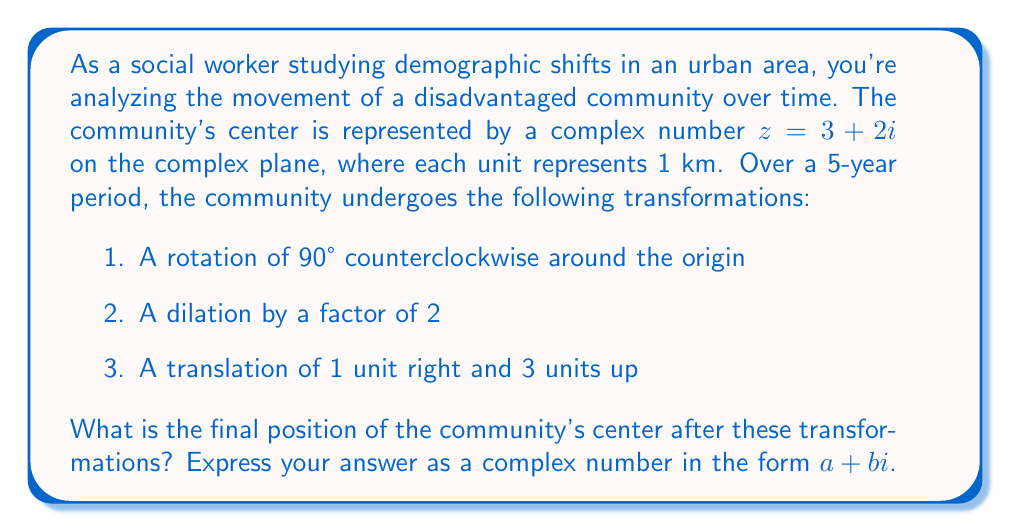Show me your answer to this math problem. Let's approach this problem step-by-step:

1. Initial position: $z = 3 + 2i$

2. Rotation of 90° counterclockwise:
   This is equivalent to multiplying by $i$:
   $$z_1 = z \cdot i = (3 + 2i) \cdot i = 3i + 2i^2 = 3i - 2 = -2 + 3i$$

3. Dilation by a factor of 2:
   Multiply the result by 2:
   $$z_2 = 2z_1 = 2(-2 + 3i) = -4 + 6i$$

4. Translation of 1 unit right and 3 units up:
   Add $1 + 3i$ to the result:
   $$z_3 = z_2 + (1 + 3i) = (-4 + 6i) + (1 + 3i) = -3 + 9i$$

Therefore, the final position of the community's center is $-3 + 9i$.

This transformation can be visualized as follows:

[asy]
import graph;
size(200);
xaxis("Re", arrow=Arrow);
yaxis("Im", arrow=Arrow);
dot((3,2), red);
dot((-2,3), green);
dot((-4,6), blue);
dot((-3,9), purple);
label("Start", (3,2), E, red);
label("After rotation", (-2,3), W, green);
label("After dilation", (-4,6), W, blue);
label("Final", (-3,9), E, purple);
draw((3,2)--(-2,3)--(-4,6)--(-3,9), arrow=Arrow);
[/asy]

This visualization shows how the community's center has moved significantly north and slightly west from its original position, reflecting a major demographic shift in the urban area.
Answer: $-3 + 9i$ 